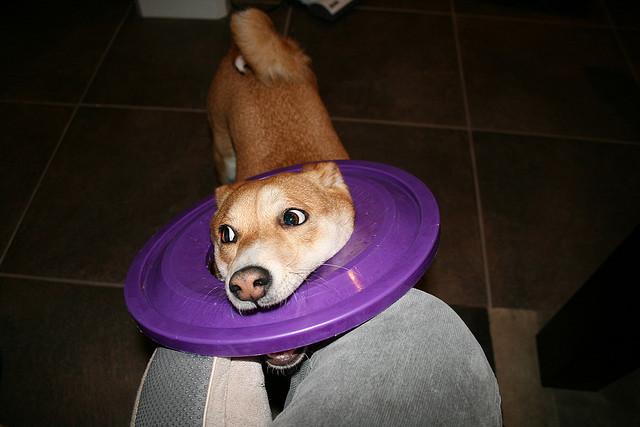What color is the Frisbee?
Write a very short answer. Purple. Is this a real dog?
Concise answer only. Yes. Did the dog catch the Frisbee?
Concise answer only. Yes. 